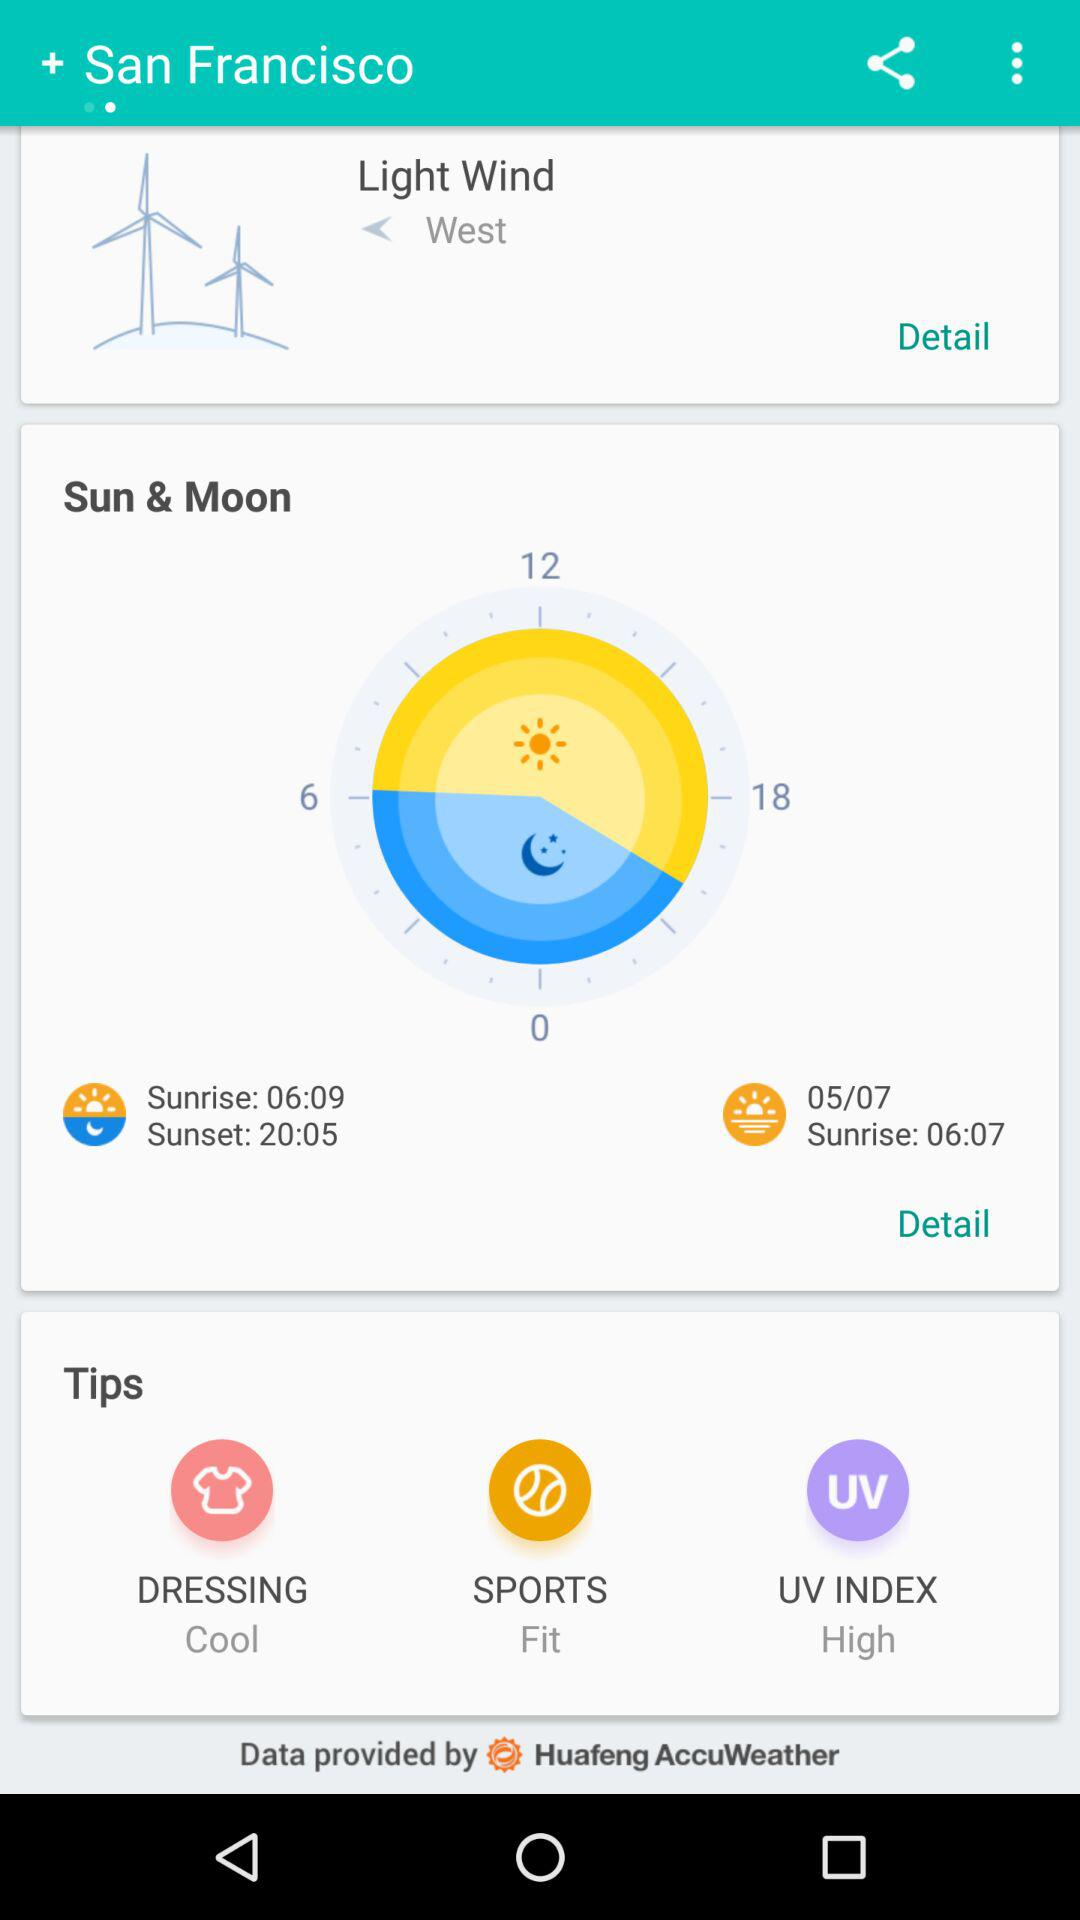What's the time for sunset? The time is 20:05. 